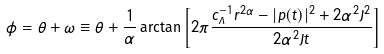<formula> <loc_0><loc_0><loc_500><loc_500>\phi = \theta + \omega \equiv \theta + \frac { 1 } { \alpha } \arctan \left [ 2 \pi \frac { c ^ { - 1 } _ { \Lambda } r ^ { 2 \alpha } - | p ( t ) | ^ { 2 } + 2 \alpha ^ { 2 } J ^ { 2 } } { 2 \alpha ^ { 2 } J t } \right ]</formula> 